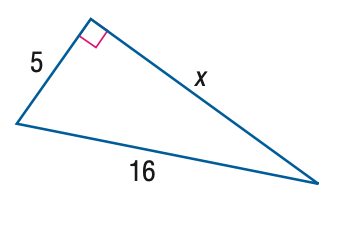Answer the mathemtical geometry problem and directly provide the correct option letter.
Question: Find x. Round to the nearest hundredth.
Choices: A: 15.20 B: 15.84 C: 16.16 D: 16.76 A 